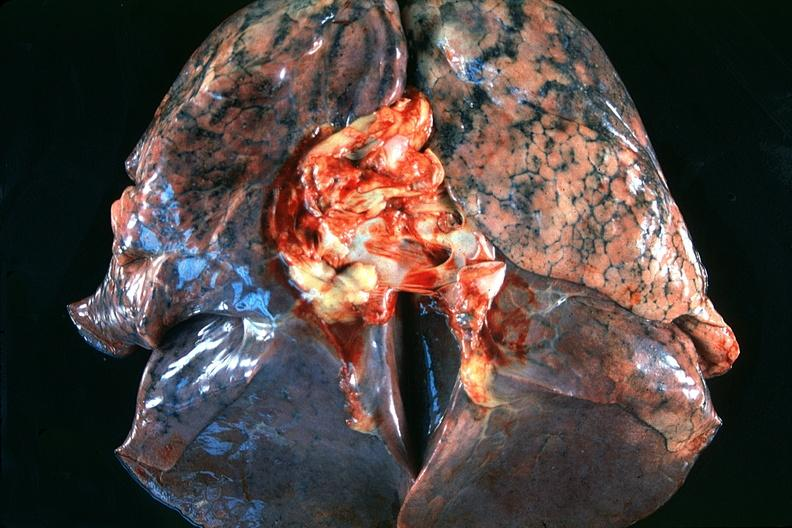s respiratory present?
Answer the question using a single word or phrase. Yes 